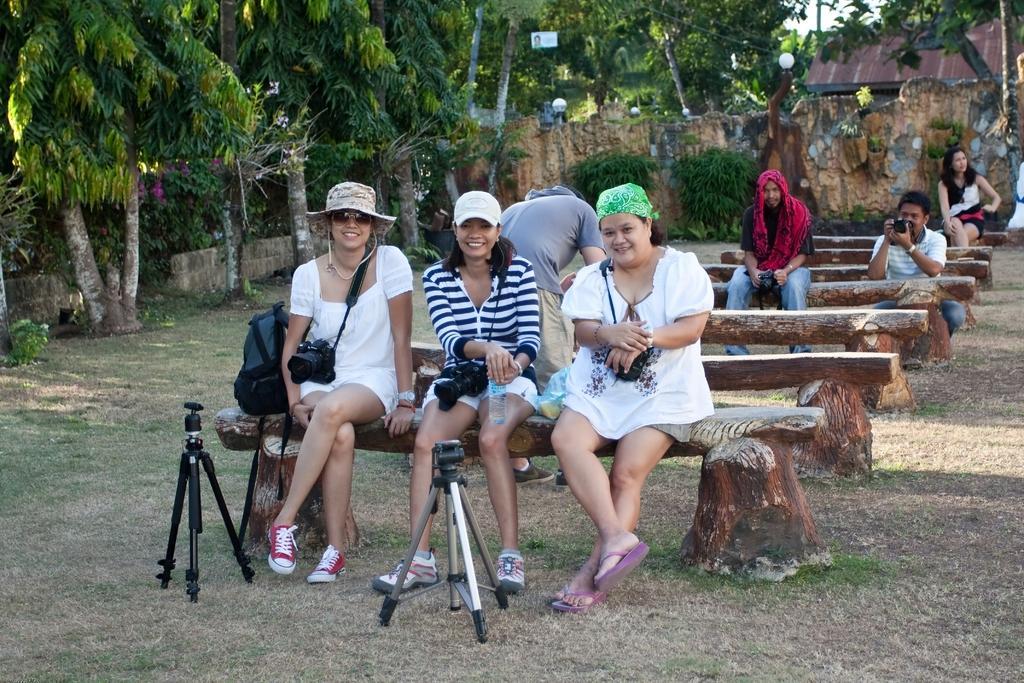Could you give a brief overview of what you see in this image? In the middle of the image three women are sitting on a table. Three of them carrying cameras. In front of them there is a tripod. Behind them there is a man standing. Top right side of the image there is a tree. Top left side of the image there is a tree. Bottom of the image there is a grass. In the middle of the image there is a wall and lights. Top right side of the image there is a man sitting. Top right side of the image there is a woman sitting. 